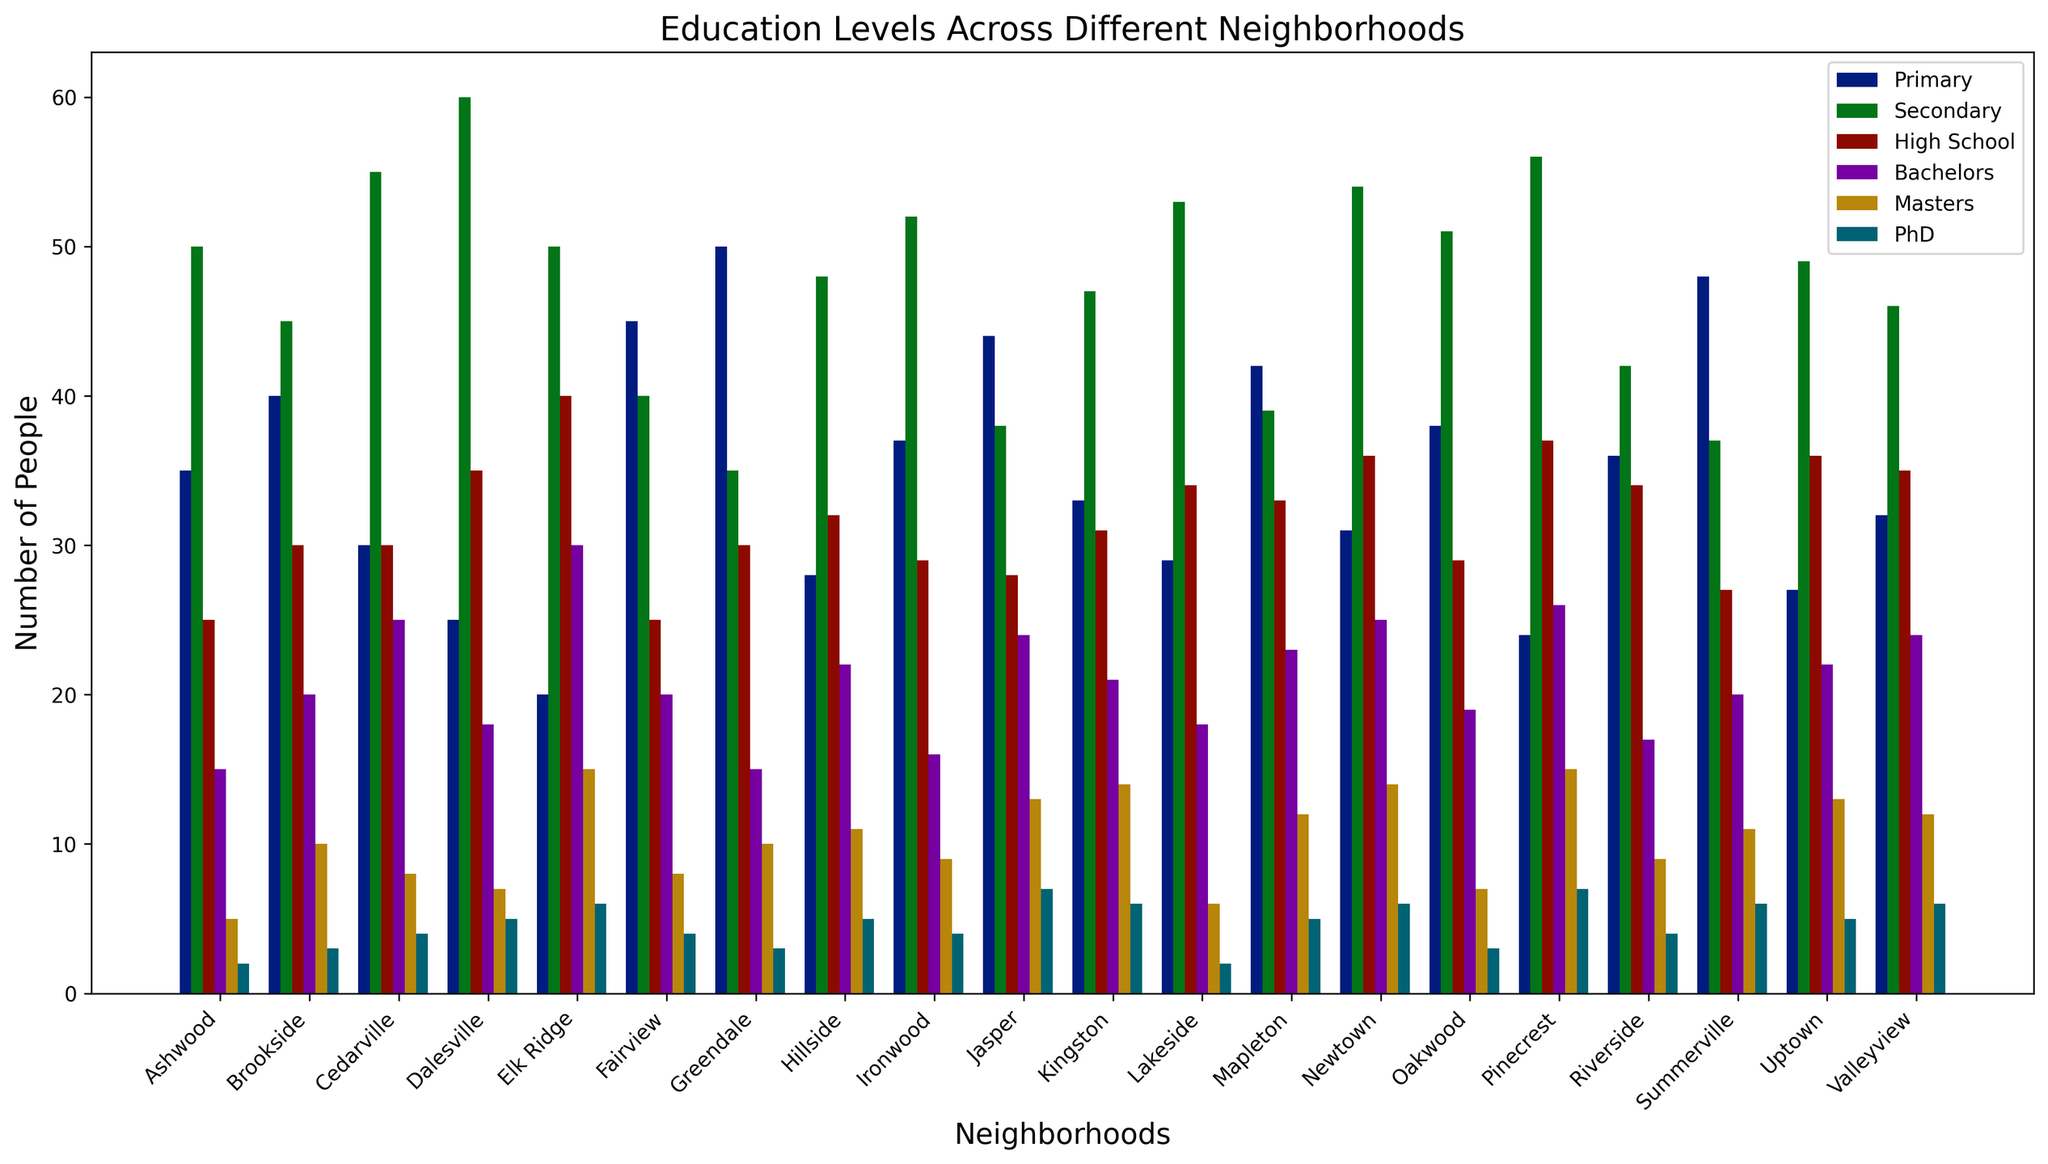Which neighborhood has the highest number of people with a PhD? To find the neighborhood with the highest number of people holding a PhD, we look at the tallest bar in the PhD section for each neighborhood. Observing all the bars labeled "PhD," Dalesville and Pinecrest each have the tallest bars with 7 people.
Answer: Dalesville and Pinecrest Which neighborhood has the lowest number of people with a primary education? To find the neighborhood with the least number of people at the primary education level, we look at the shortest bar in the Primary section. The shortest bar is for Elk Ridge with 20 people.
Answer: Elk Ridge How many more people have a Bachelors degree in Elk Ridge compared to Hillside? To determine the difference, check the Bachelors category for both neighborhoods. Elk Ridge has 30 people while Hillside has 22. Compute the difference: 30 - 22 = 8.
Answer: 8 Which education level has the most people in Fairview? To find the most populous education level, examine the bar heights for all categories in Fairview. The tallest bar is Primary education with 45 people.
Answer: Primary How many people in total have a Master's or PhD in Oakwood? Add the number of people with a Master's and those with a PhD in Oakwood: 7 (Masters) + 3 (PhD) = 10.
Answer: 10 Which neighborhood has more people with Secondary education, Ashwood or Lakeside? Compare the Secondary education bar heights between Ashwood (50 people) and Lakeside (53 people). Lakeside has more.
Answer: Lakeside What is the combined total of people with a High School education in Uptown and Jasper? Add the number of people with High School education in both neighborhoods: 36 (Uptown) + 28 (Jasper) = 64.
Answer: 64 Which neighborhood has the most varied levels of education (most diverse bar heights)? To determine the most varied education levels, observe the bar height differences among education categories in each neighborhood. Cedarville shows significant variation with bars ranging from 30 to 55.
Answer: Cedarville What is the average number of people with a Bachelor's degree across all neighborhoods? Sum the Bachelor degree numbers for all neighborhoods and divide by the total number of neighborhoods: (15+20+25+18+30+20+15+22+16+24+21+18+23+25+19+26+17+20+24)/19 = 421/19 = 22.16.
Answer: 22.16 